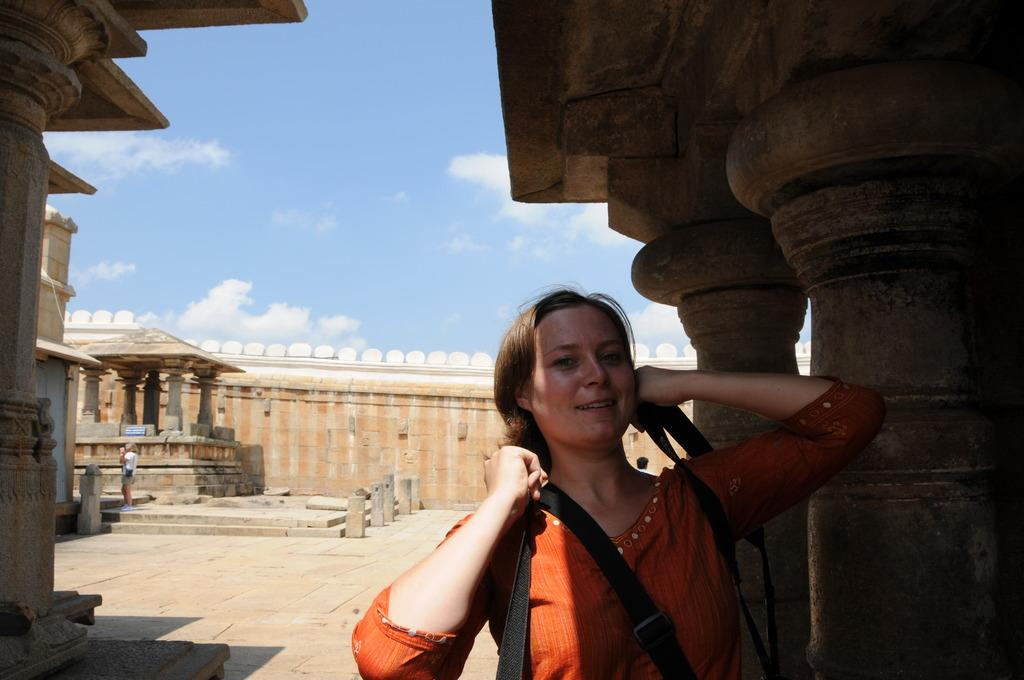What is the main subject of the image? There is a beautiful woman in the image. What is the woman wearing? The woman is wearing an orange dress. What type of artwork is the image? The image is a sculpture. What is the weather like in the image? The sky is visible at the top of the image, and it is sunny. What type of food is being measured in the image? There is no food or measuring activity present in the image. 